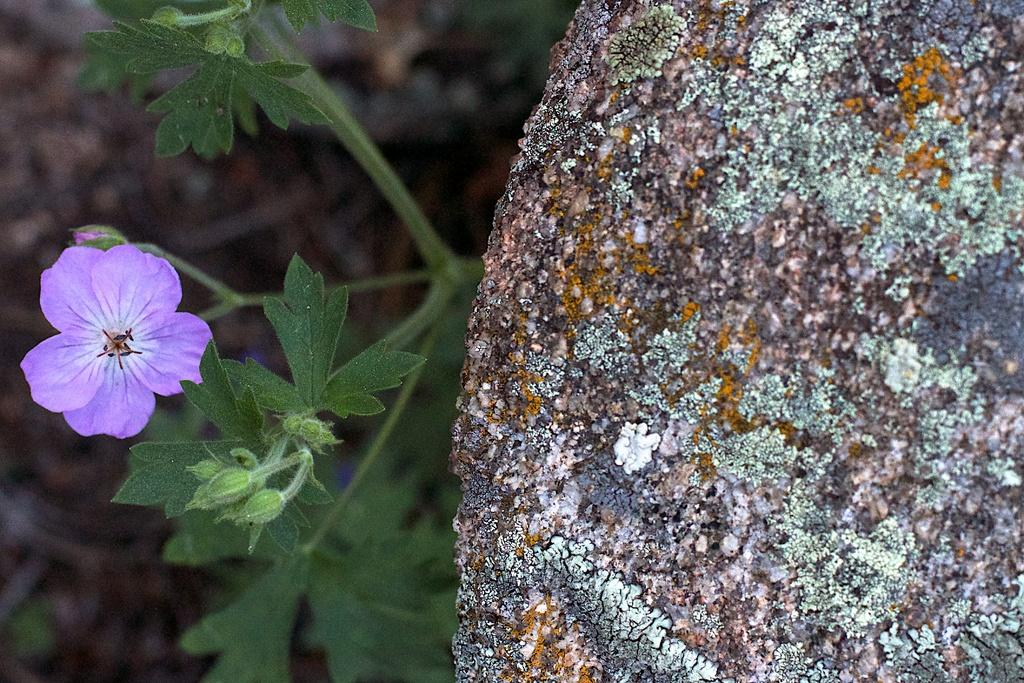What type of plant is on the left side of the image? There is a plant on the left side of the image. What stage of growth are the buds on the plant? The plant has buds, which are indicative of a stage of growth before fully blooming. What other features can be seen on the plant? The plant has flowers. What is located on the right side of the image? There is a rock on the right side of the image. How would you describe the background of the image? The background of the image is blurry. What time does the clock show in the image? There is no clock present in the image. Can you describe the horse's behavior in the image? There is no horse present in the image. 